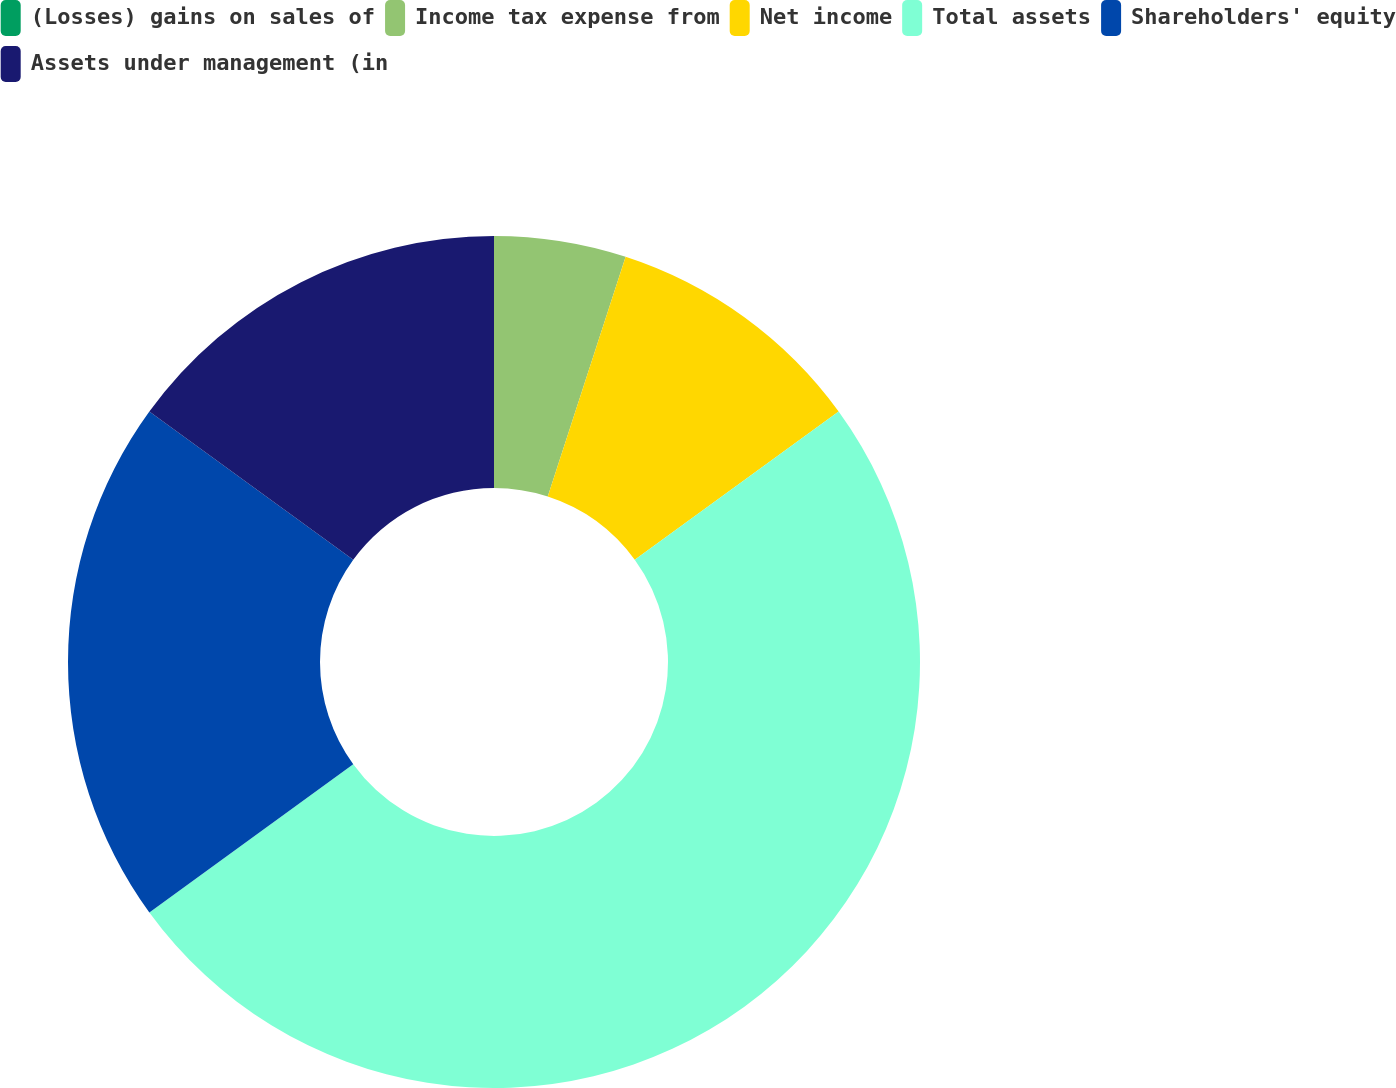Convert chart to OTSL. <chart><loc_0><loc_0><loc_500><loc_500><pie_chart><fcel>(Losses) gains on sales of<fcel>Income tax expense from<fcel>Net income<fcel>Total assets<fcel>Shareholders' equity<fcel>Assets under management (in<nl><fcel>0.0%<fcel>5.0%<fcel>10.0%<fcel>50.0%<fcel>20.0%<fcel>15.0%<nl></chart> 